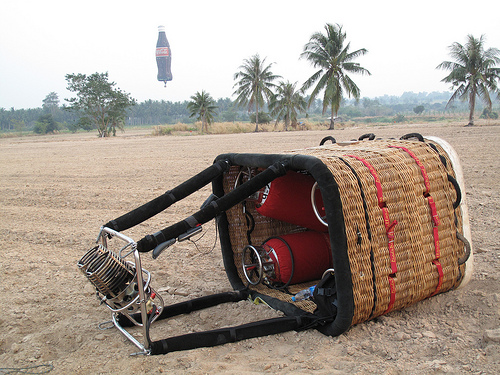<image>
Is there a soda above the ground? Yes. The soda is positioned above the ground in the vertical space, higher up in the scene. 